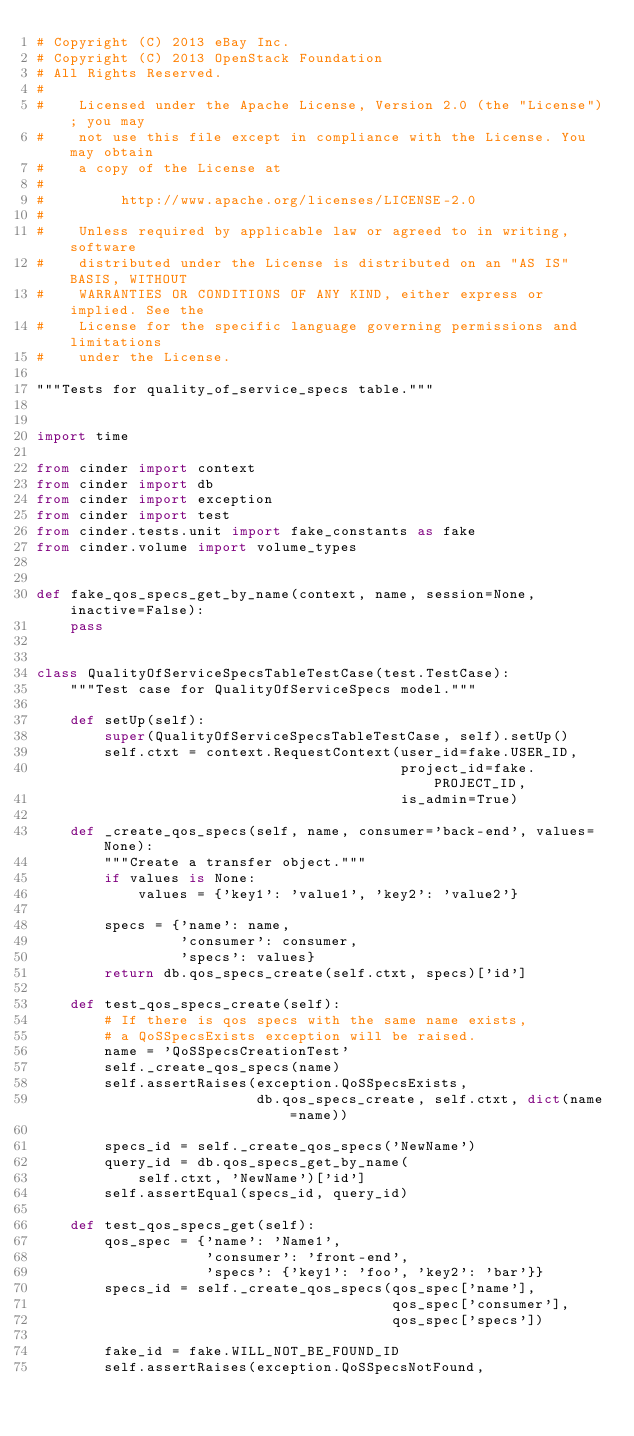Convert code to text. <code><loc_0><loc_0><loc_500><loc_500><_Python_># Copyright (C) 2013 eBay Inc.
# Copyright (C) 2013 OpenStack Foundation
# All Rights Reserved.
#
#    Licensed under the Apache License, Version 2.0 (the "License"); you may
#    not use this file except in compliance with the License. You may obtain
#    a copy of the License at
#
#         http://www.apache.org/licenses/LICENSE-2.0
#
#    Unless required by applicable law or agreed to in writing, software
#    distributed under the License is distributed on an "AS IS" BASIS, WITHOUT
#    WARRANTIES OR CONDITIONS OF ANY KIND, either express or implied. See the
#    License for the specific language governing permissions and limitations
#    under the License.

"""Tests for quality_of_service_specs table."""


import time

from cinder import context
from cinder import db
from cinder import exception
from cinder import test
from cinder.tests.unit import fake_constants as fake
from cinder.volume import volume_types


def fake_qos_specs_get_by_name(context, name, session=None, inactive=False):
    pass


class QualityOfServiceSpecsTableTestCase(test.TestCase):
    """Test case for QualityOfServiceSpecs model."""

    def setUp(self):
        super(QualityOfServiceSpecsTableTestCase, self).setUp()
        self.ctxt = context.RequestContext(user_id=fake.USER_ID,
                                           project_id=fake.PROJECT_ID,
                                           is_admin=True)

    def _create_qos_specs(self, name, consumer='back-end', values=None):
        """Create a transfer object."""
        if values is None:
            values = {'key1': 'value1', 'key2': 'value2'}

        specs = {'name': name,
                 'consumer': consumer,
                 'specs': values}
        return db.qos_specs_create(self.ctxt, specs)['id']

    def test_qos_specs_create(self):
        # If there is qos specs with the same name exists,
        # a QoSSpecsExists exception will be raised.
        name = 'QoSSpecsCreationTest'
        self._create_qos_specs(name)
        self.assertRaises(exception.QoSSpecsExists,
                          db.qos_specs_create, self.ctxt, dict(name=name))

        specs_id = self._create_qos_specs('NewName')
        query_id = db.qos_specs_get_by_name(
            self.ctxt, 'NewName')['id']
        self.assertEqual(specs_id, query_id)

    def test_qos_specs_get(self):
        qos_spec = {'name': 'Name1',
                    'consumer': 'front-end',
                    'specs': {'key1': 'foo', 'key2': 'bar'}}
        specs_id = self._create_qos_specs(qos_spec['name'],
                                          qos_spec['consumer'],
                                          qos_spec['specs'])

        fake_id = fake.WILL_NOT_BE_FOUND_ID
        self.assertRaises(exception.QoSSpecsNotFound,</code> 